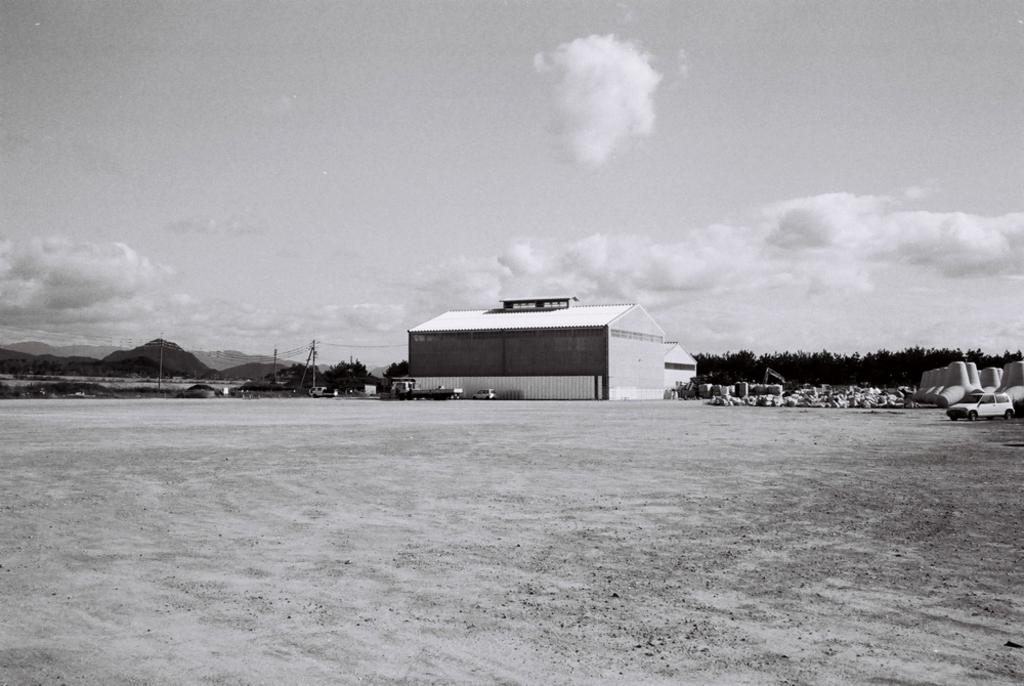What types of vehicles are in the image? There are vehicles in the image, but the specific types are not mentioned. What structure can be seen in the image? There is a shed in the image. What natural features are visible in the background of the image? Mountains and trees are visible in the background of the image. What is the condition of the sky in the image? The sky is clear in the image. Can you see a horse applying polish to a patch in the image? No, there is no horse or any activity involving polish or patches in the image. 